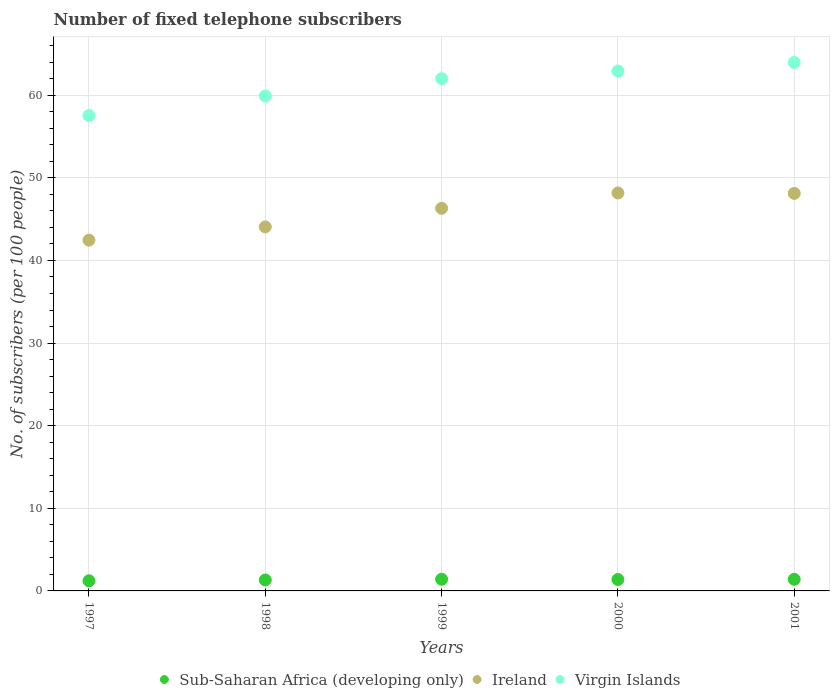How many different coloured dotlines are there?
Make the answer very short. 3. Is the number of dotlines equal to the number of legend labels?
Provide a short and direct response. Yes. What is the number of fixed telephone subscribers in Virgin Islands in 2001?
Your answer should be very brief. 63.96. Across all years, what is the maximum number of fixed telephone subscribers in Ireland?
Your answer should be compact. 48.16. Across all years, what is the minimum number of fixed telephone subscribers in Ireland?
Keep it short and to the point. 42.45. In which year was the number of fixed telephone subscribers in Sub-Saharan Africa (developing only) maximum?
Ensure brevity in your answer.  1999. What is the total number of fixed telephone subscribers in Ireland in the graph?
Your answer should be compact. 229.1. What is the difference between the number of fixed telephone subscribers in Ireland in 1997 and that in 1999?
Your answer should be very brief. -3.85. What is the difference between the number of fixed telephone subscribers in Sub-Saharan Africa (developing only) in 1997 and the number of fixed telephone subscribers in Virgin Islands in 2000?
Give a very brief answer. -61.7. What is the average number of fixed telephone subscribers in Ireland per year?
Provide a succinct answer. 45.82. In the year 1997, what is the difference between the number of fixed telephone subscribers in Virgin Islands and number of fixed telephone subscribers in Sub-Saharan Africa (developing only)?
Your response must be concise. 56.31. What is the ratio of the number of fixed telephone subscribers in Ireland in 1997 to that in 1998?
Provide a short and direct response. 0.96. Is the difference between the number of fixed telephone subscribers in Virgin Islands in 1999 and 2000 greater than the difference between the number of fixed telephone subscribers in Sub-Saharan Africa (developing only) in 1999 and 2000?
Offer a terse response. No. What is the difference between the highest and the second highest number of fixed telephone subscribers in Virgin Islands?
Your answer should be very brief. 1.03. What is the difference between the highest and the lowest number of fixed telephone subscribers in Sub-Saharan Africa (developing only)?
Your answer should be very brief. 0.19. In how many years, is the number of fixed telephone subscribers in Sub-Saharan Africa (developing only) greater than the average number of fixed telephone subscribers in Sub-Saharan Africa (developing only) taken over all years?
Offer a very short reply. 3. Does the number of fixed telephone subscribers in Ireland monotonically increase over the years?
Provide a short and direct response. No. Is the number of fixed telephone subscribers in Ireland strictly less than the number of fixed telephone subscribers in Virgin Islands over the years?
Offer a very short reply. Yes. How many years are there in the graph?
Keep it short and to the point. 5. What is the difference between two consecutive major ticks on the Y-axis?
Offer a terse response. 10. Are the values on the major ticks of Y-axis written in scientific E-notation?
Ensure brevity in your answer.  No. Does the graph contain any zero values?
Give a very brief answer. No. Does the graph contain grids?
Your answer should be compact. Yes. Where does the legend appear in the graph?
Ensure brevity in your answer.  Bottom center. What is the title of the graph?
Your response must be concise. Number of fixed telephone subscribers. What is the label or title of the X-axis?
Offer a very short reply. Years. What is the label or title of the Y-axis?
Provide a succinct answer. No. of subscribers (per 100 people). What is the No. of subscribers (per 100 people) of Sub-Saharan Africa (developing only) in 1997?
Your answer should be compact. 1.23. What is the No. of subscribers (per 100 people) in Ireland in 1997?
Your answer should be very brief. 42.45. What is the No. of subscribers (per 100 people) in Virgin Islands in 1997?
Give a very brief answer. 57.54. What is the No. of subscribers (per 100 people) in Sub-Saharan Africa (developing only) in 1998?
Give a very brief answer. 1.32. What is the No. of subscribers (per 100 people) of Ireland in 1998?
Your answer should be very brief. 44.06. What is the No. of subscribers (per 100 people) in Virgin Islands in 1998?
Give a very brief answer. 59.9. What is the No. of subscribers (per 100 people) in Sub-Saharan Africa (developing only) in 1999?
Offer a very short reply. 1.41. What is the No. of subscribers (per 100 people) in Ireland in 1999?
Your answer should be very brief. 46.31. What is the No. of subscribers (per 100 people) of Virgin Islands in 1999?
Give a very brief answer. 62. What is the No. of subscribers (per 100 people) of Sub-Saharan Africa (developing only) in 2000?
Ensure brevity in your answer.  1.38. What is the No. of subscribers (per 100 people) of Ireland in 2000?
Keep it short and to the point. 48.16. What is the No. of subscribers (per 100 people) in Virgin Islands in 2000?
Your answer should be very brief. 62.93. What is the No. of subscribers (per 100 people) of Sub-Saharan Africa (developing only) in 2001?
Offer a terse response. 1.4. What is the No. of subscribers (per 100 people) in Ireland in 2001?
Give a very brief answer. 48.11. What is the No. of subscribers (per 100 people) in Virgin Islands in 2001?
Make the answer very short. 63.96. Across all years, what is the maximum No. of subscribers (per 100 people) in Sub-Saharan Africa (developing only)?
Your response must be concise. 1.41. Across all years, what is the maximum No. of subscribers (per 100 people) of Ireland?
Your answer should be compact. 48.16. Across all years, what is the maximum No. of subscribers (per 100 people) of Virgin Islands?
Offer a very short reply. 63.96. Across all years, what is the minimum No. of subscribers (per 100 people) of Sub-Saharan Africa (developing only)?
Make the answer very short. 1.23. Across all years, what is the minimum No. of subscribers (per 100 people) of Ireland?
Your answer should be very brief. 42.45. Across all years, what is the minimum No. of subscribers (per 100 people) in Virgin Islands?
Give a very brief answer. 57.54. What is the total No. of subscribers (per 100 people) in Sub-Saharan Africa (developing only) in the graph?
Provide a short and direct response. 6.75. What is the total No. of subscribers (per 100 people) of Ireland in the graph?
Provide a succinct answer. 229.1. What is the total No. of subscribers (per 100 people) of Virgin Islands in the graph?
Provide a short and direct response. 306.32. What is the difference between the No. of subscribers (per 100 people) of Sub-Saharan Africa (developing only) in 1997 and that in 1998?
Your answer should be compact. -0.09. What is the difference between the No. of subscribers (per 100 people) in Ireland in 1997 and that in 1998?
Provide a short and direct response. -1.6. What is the difference between the No. of subscribers (per 100 people) of Virgin Islands in 1997 and that in 1998?
Offer a very short reply. -2.36. What is the difference between the No. of subscribers (per 100 people) in Sub-Saharan Africa (developing only) in 1997 and that in 1999?
Give a very brief answer. -0.19. What is the difference between the No. of subscribers (per 100 people) in Ireland in 1997 and that in 1999?
Your answer should be compact. -3.85. What is the difference between the No. of subscribers (per 100 people) in Virgin Islands in 1997 and that in 1999?
Make the answer very short. -4.47. What is the difference between the No. of subscribers (per 100 people) in Sub-Saharan Africa (developing only) in 1997 and that in 2000?
Your answer should be very brief. -0.15. What is the difference between the No. of subscribers (per 100 people) in Ireland in 1997 and that in 2000?
Your response must be concise. -5.71. What is the difference between the No. of subscribers (per 100 people) of Virgin Islands in 1997 and that in 2000?
Give a very brief answer. -5.39. What is the difference between the No. of subscribers (per 100 people) in Sub-Saharan Africa (developing only) in 1997 and that in 2001?
Ensure brevity in your answer.  -0.17. What is the difference between the No. of subscribers (per 100 people) in Ireland in 1997 and that in 2001?
Make the answer very short. -5.66. What is the difference between the No. of subscribers (per 100 people) in Virgin Islands in 1997 and that in 2001?
Provide a short and direct response. -6.42. What is the difference between the No. of subscribers (per 100 people) of Sub-Saharan Africa (developing only) in 1998 and that in 1999?
Your answer should be compact. -0.09. What is the difference between the No. of subscribers (per 100 people) in Ireland in 1998 and that in 1999?
Your response must be concise. -2.25. What is the difference between the No. of subscribers (per 100 people) in Virgin Islands in 1998 and that in 1999?
Ensure brevity in your answer.  -2.1. What is the difference between the No. of subscribers (per 100 people) of Sub-Saharan Africa (developing only) in 1998 and that in 2000?
Keep it short and to the point. -0.06. What is the difference between the No. of subscribers (per 100 people) in Ireland in 1998 and that in 2000?
Make the answer very short. -4.11. What is the difference between the No. of subscribers (per 100 people) in Virgin Islands in 1998 and that in 2000?
Keep it short and to the point. -3.03. What is the difference between the No. of subscribers (per 100 people) in Sub-Saharan Africa (developing only) in 1998 and that in 2001?
Ensure brevity in your answer.  -0.08. What is the difference between the No. of subscribers (per 100 people) in Ireland in 1998 and that in 2001?
Your response must be concise. -4.06. What is the difference between the No. of subscribers (per 100 people) in Virgin Islands in 1998 and that in 2001?
Offer a terse response. -4.06. What is the difference between the No. of subscribers (per 100 people) of Sub-Saharan Africa (developing only) in 1999 and that in 2000?
Your answer should be compact. 0.03. What is the difference between the No. of subscribers (per 100 people) in Ireland in 1999 and that in 2000?
Your response must be concise. -1.85. What is the difference between the No. of subscribers (per 100 people) of Virgin Islands in 1999 and that in 2000?
Make the answer very short. -0.93. What is the difference between the No. of subscribers (per 100 people) of Sub-Saharan Africa (developing only) in 1999 and that in 2001?
Offer a terse response. 0.01. What is the difference between the No. of subscribers (per 100 people) of Ireland in 1999 and that in 2001?
Provide a succinct answer. -1.8. What is the difference between the No. of subscribers (per 100 people) of Virgin Islands in 1999 and that in 2001?
Provide a succinct answer. -1.96. What is the difference between the No. of subscribers (per 100 people) of Sub-Saharan Africa (developing only) in 2000 and that in 2001?
Offer a very short reply. -0.02. What is the difference between the No. of subscribers (per 100 people) in Ireland in 2000 and that in 2001?
Offer a terse response. 0.05. What is the difference between the No. of subscribers (per 100 people) in Virgin Islands in 2000 and that in 2001?
Ensure brevity in your answer.  -1.03. What is the difference between the No. of subscribers (per 100 people) in Sub-Saharan Africa (developing only) in 1997 and the No. of subscribers (per 100 people) in Ireland in 1998?
Your answer should be very brief. -42.83. What is the difference between the No. of subscribers (per 100 people) in Sub-Saharan Africa (developing only) in 1997 and the No. of subscribers (per 100 people) in Virgin Islands in 1998?
Offer a very short reply. -58.67. What is the difference between the No. of subscribers (per 100 people) in Ireland in 1997 and the No. of subscribers (per 100 people) in Virgin Islands in 1998?
Make the answer very short. -17.44. What is the difference between the No. of subscribers (per 100 people) of Sub-Saharan Africa (developing only) in 1997 and the No. of subscribers (per 100 people) of Ireland in 1999?
Make the answer very short. -45.08. What is the difference between the No. of subscribers (per 100 people) in Sub-Saharan Africa (developing only) in 1997 and the No. of subscribers (per 100 people) in Virgin Islands in 1999?
Ensure brevity in your answer.  -60.77. What is the difference between the No. of subscribers (per 100 people) of Ireland in 1997 and the No. of subscribers (per 100 people) of Virgin Islands in 1999?
Ensure brevity in your answer.  -19.55. What is the difference between the No. of subscribers (per 100 people) of Sub-Saharan Africa (developing only) in 1997 and the No. of subscribers (per 100 people) of Ireland in 2000?
Your response must be concise. -46.93. What is the difference between the No. of subscribers (per 100 people) in Sub-Saharan Africa (developing only) in 1997 and the No. of subscribers (per 100 people) in Virgin Islands in 2000?
Offer a terse response. -61.7. What is the difference between the No. of subscribers (per 100 people) in Ireland in 1997 and the No. of subscribers (per 100 people) in Virgin Islands in 2000?
Provide a succinct answer. -20.47. What is the difference between the No. of subscribers (per 100 people) of Sub-Saharan Africa (developing only) in 1997 and the No. of subscribers (per 100 people) of Ireland in 2001?
Give a very brief answer. -46.88. What is the difference between the No. of subscribers (per 100 people) of Sub-Saharan Africa (developing only) in 1997 and the No. of subscribers (per 100 people) of Virgin Islands in 2001?
Offer a terse response. -62.73. What is the difference between the No. of subscribers (per 100 people) of Ireland in 1997 and the No. of subscribers (per 100 people) of Virgin Islands in 2001?
Your answer should be compact. -21.5. What is the difference between the No. of subscribers (per 100 people) of Sub-Saharan Africa (developing only) in 1998 and the No. of subscribers (per 100 people) of Ireland in 1999?
Your answer should be compact. -44.99. What is the difference between the No. of subscribers (per 100 people) in Sub-Saharan Africa (developing only) in 1998 and the No. of subscribers (per 100 people) in Virgin Islands in 1999?
Your response must be concise. -60.68. What is the difference between the No. of subscribers (per 100 people) in Ireland in 1998 and the No. of subscribers (per 100 people) in Virgin Islands in 1999?
Provide a short and direct response. -17.95. What is the difference between the No. of subscribers (per 100 people) of Sub-Saharan Africa (developing only) in 1998 and the No. of subscribers (per 100 people) of Ireland in 2000?
Keep it short and to the point. -46.84. What is the difference between the No. of subscribers (per 100 people) in Sub-Saharan Africa (developing only) in 1998 and the No. of subscribers (per 100 people) in Virgin Islands in 2000?
Your answer should be very brief. -61.6. What is the difference between the No. of subscribers (per 100 people) in Ireland in 1998 and the No. of subscribers (per 100 people) in Virgin Islands in 2000?
Your answer should be compact. -18.87. What is the difference between the No. of subscribers (per 100 people) in Sub-Saharan Africa (developing only) in 1998 and the No. of subscribers (per 100 people) in Ireland in 2001?
Keep it short and to the point. -46.79. What is the difference between the No. of subscribers (per 100 people) of Sub-Saharan Africa (developing only) in 1998 and the No. of subscribers (per 100 people) of Virgin Islands in 2001?
Your answer should be very brief. -62.63. What is the difference between the No. of subscribers (per 100 people) in Ireland in 1998 and the No. of subscribers (per 100 people) in Virgin Islands in 2001?
Keep it short and to the point. -19.9. What is the difference between the No. of subscribers (per 100 people) of Sub-Saharan Africa (developing only) in 1999 and the No. of subscribers (per 100 people) of Ireland in 2000?
Your response must be concise. -46.75. What is the difference between the No. of subscribers (per 100 people) of Sub-Saharan Africa (developing only) in 1999 and the No. of subscribers (per 100 people) of Virgin Islands in 2000?
Your answer should be compact. -61.51. What is the difference between the No. of subscribers (per 100 people) in Ireland in 1999 and the No. of subscribers (per 100 people) in Virgin Islands in 2000?
Make the answer very short. -16.62. What is the difference between the No. of subscribers (per 100 people) in Sub-Saharan Africa (developing only) in 1999 and the No. of subscribers (per 100 people) in Ireland in 2001?
Your answer should be compact. -46.7. What is the difference between the No. of subscribers (per 100 people) in Sub-Saharan Africa (developing only) in 1999 and the No. of subscribers (per 100 people) in Virgin Islands in 2001?
Offer a very short reply. -62.54. What is the difference between the No. of subscribers (per 100 people) in Ireland in 1999 and the No. of subscribers (per 100 people) in Virgin Islands in 2001?
Your answer should be compact. -17.65. What is the difference between the No. of subscribers (per 100 people) in Sub-Saharan Africa (developing only) in 2000 and the No. of subscribers (per 100 people) in Ireland in 2001?
Offer a terse response. -46.73. What is the difference between the No. of subscribers (per 100 people) of Sub-Saharan Africa (developing only) in 2000 and the No. of subscribers (per 100 people) of Virgin Islands in 2001?
Your answer should be compact. -62.58. What is the difference between the No. of subscribers (per 100 people) in Ireland in 2000 and the No. of subscribers (per 100 people) in Virgin Islands in 2001?
Make the answer very short. -15.79. What is the average No. of subscribers (per 100 people) in Sub-Saharan Africa (developing only) per year?
Ensure brevity in your answer.  1.35. What is the average No. of subscribers (per 100 people) in Ireland per year?
Offer a terse response. 45.82. What is the average No. of subscribers (per 100 people) of Virgin Islands per year?
Provide a succinct answer. 61.26. In the year 1997, what is the difference between the No. of subscribers (per 100 people) of Sub-Saharan Africa (developing only) and No. of subscribers (per 100 people) of Ireland?
Offer a terse response. -41.23. In the year 1997, what is the difference between the No. of subscribers (per 100 people) of Sub-Saharan Africa (developing only) and No. of subscribers (per 100 people) of Virgin Islands?
Ensure brevity in your answer.  -56.31. In the year 1997, what is the difference between the No. of subscribers (per 100 people) in Ireland and No. of subscribers (per 100 people) in Virgin Islands?
Provide a succinct answer. -15.08. In the year 1998, what is the difference between the No. of subscribers (per 100 people) in Sub-Saharan Africa (developing only) and No. of subscribers (per 100 people) in Ireland?
Your response must be concise. -42.73. In the year 1998, what is the difference between the No. of subscribers (per 100 people) of Sub-Saharan Africa (developing only) and No. of subscribers (per 100 people) of Virgin Islands?
Make the answer very short. -58.57. In the year 1998, what is the difference between the No. of subscribers (per 100 people) of Ireland and No. of subscribers (per 100 people) of Virgin Islands?
Offer a very short reply. -15.84. In the year 1999, what is the difference between the No. of subscribers (per 100 people) of Sub-Saharan Africa (developing only) and No. of subscribers (per 100 people) of Ireland?
Your answer should be compact. -44.89. In the year 1999, what is the difference between the No. of subscribers (per 100 people) of Sub-Saharan Africa (developing only) and No. of subscribers (per 100 people) of Virgin Islands?
Your response must be concise. -60.59. In the year 1999, what is the difference between the No. of subscribers (per 100 people) of Ireland and No. of subscribers (per 100 people) of Virgin Islands?
Give a very brief answer. -15.69. In the year 2000, what is the difference between the No. of subscribers (per 100 people) of Sub-Saharan Africa (developing only) and No. of subscribers (per 100 people) of Ireland?
Your answer should be compact. -46.78. In the year 2000, what is the difference between the No. of subscribers (per 100 people) of Sub-Saharan Africa (developing only) and No. of subscribers (per 100 people) of Virgin Islands?
Provide a succinct answer. -61.55. In the year 2000, what is the difference between the No. of subscribers (per 100 people) in Ireland and No. of subscribers (per 100 people) in Virgin Islands?
Make the answer very short. -14.76. In the year 2001, what is the difference between the No. of subscribers (per 100 people) in Sub-Saharan Africa (developing only) and No. of subscribers (per 100 people) in Ireland?
Provide a short and direct response. -46.71. In the year 2001, what is the difference between the No. of subscribers (per 100 people) of Sub-Saharan Africa (developing only) and No. of subscribers (per 100 people) of Virgin Islands?
Keep it short and to the point. -62.55. In the year 2001, what is the difference between the No. of subscribers (per 100 people) of Ireland and No. of subscribers (per 100 people) of Virgin Islands?
Your answer should be compact. -15.84. What is the ratio of the No. of subscribers (per 100 people) in Sub-Saharan Africa (developing only) in 1997 to that in 1998?
Your answer should be compact. 0.93. What is the ratio of the No. of subscribers (per 100 people) in Ireland in 1997 to that in 1998?
Ensure brevity in your answer.  0.96. What is the ratio of the No. of subscribers (per 100 people) of Virgin Islands in 1997 to that in 1998?
Offer a very short reply. 0.96. What is the ratio of the No. of subscribers (per 100 people) of Sub-Saharan Africa (developing only) in 1997 to that in 1999?
Give a very brief answer. 0.87. What is the ratio of the No. of subscribers (per 100 people) in Ireland in 1997 to that in 1999?
Provide a succinct answer. 0.92. What is the ratio of the No. of subscribers (per 100 people) in Virgin Islands in 1997 to that in 1999?
Your response must be concise. 0.93. What is the ratio of the No. of subscribers (per 100 people) of Sub-Saharan Africa (developing only) in 1997 to that in 2000?
Provide a short and direct response. 0.89. What is the ratio of the No. of subscribers (per 100 people) in Ireland in 1997 to that in 2000?
Ensure brevity in your answer.  0.88. What is the ratio of the No. of subscribers (per 100 people) of Virgin Islands in 1997 to that in 2000?
Ensure brevity in your answer.  0.91. What is the ratio of the No. of subscribers (per 100 people) of Sub-Saharan Africa (developing only) in 1997 to that in 2001?
Keep it short and to the point. 0.88. What is the ratio of the No. of subscribers (per 100 people) of Ireland in 1997 to that in 2001?
Offer a terse response. 0.88. What is the ratio of the No. of subscribers (per 100 people) in Virgin Islands in 1997 to that in 2001?
Provide a succinct answer. 0.9. What is the ratio of the No. of subscribers (per 100 people) in Sub-Saharan Africa (developing only) in 1998 to that in 1999?
Provide a short and direct response. 0.93. What is the ratio of the No. of subscribers (per 100 people) of Ireland in 1998 to that in 1999?
Provide a short and direct response. 0.95. What is the ratio of the No. of subscribers (per 100 people) in Virgin Islands in 1998 to that in 1999?
Your answer should be very brief. 0.97. What is the ratio of the No. of subscribers (per 100 people) in Sub-Saharan Africa (developing only) in 1998 to that in 2000?
Offer a terse response. 0.96. What is the ratio of the No. of subscribers (per 100 people) of Ireland in 1998 to that in 2000?
Make the answer very short. 0.91. What is the ratio of the No. of subscribers (per 100 people) in Virgin Islands in 1998 to that in 2000?
Keep it short and to the point. 0.95. What is the ratio of the No. of subscribers (per 100 people) in Sub-Saharan Africa (developing only) in 1998 to that in 2001?
Your answer should be compact. 0.94. What is the ratio of the No. of subscribers (per 100 people) of Ireland in 1998 to that in 2001?
Ensure brevity in your answer.  0.92. What is the ratio of the No. of subscribers (per 100 people) of Virgin Islands in 1998 to that in 2001?
Offer a terse response. 0.94. What is the ratio of the No. of subscribers (per 100 people) in Sub-Saharan Africa (developing only) in 1999 to that in 2000?
Ensure brevity in your answer.  1.02. What is the ratio of the No. of subscribers (per 100 people) of Ireland in 1999 to that in 2000?
Your response must be concise. 0.96. What is the ratio of the No. of subscribers (per 100 people) of Virgin Islands in 1999 to that in 2000?
Keep it short and to the point. 0.99. What is the ratio of the No. of subscribers (per 100 people) in Sub-Saharan Africa (developing only) in 1999 to that in 2001?
Keep it short and to the point. 1.01. What is the ratio of the No. of subscribers (per 100 people) of Ireland in 1999 to that in 2001?
Provide a short and direct response. 0.96. What is the ratio of the No. of subscribers (per 100 people) of Virgin Islands in 1999 to that in 2001?
Your response must be concise. 0.97. What is the ratio of the No. of subscribers (per 100 people) in Sub-Saharan Africa (developing only) in 2000 to that in 2001?
Your answer should be compact. 0.98. What is the ratio of the No. of subscribers (per 100 people) in Virgin Islands in 2000 to that in 2001?
Provide a short and direct response. 0.98. What is the difference between the highest and the second highest No. of subscribers (per 100 people) in Sub-Saharan Africa (developing only)?
Provide a succinct answer. 0.01. What is the difference between the highest and the second highest No. of subscribers (per 100 people) in Ireland?
Provide a succinct answer. 0.05. What is the difference between the highest and the second highest No. of subscribers (per 100 people) of Virgin Islands?
Give a very brief answer. 1.03. What is the difference between the highest and the lowest No. of subscribers (per 100 people) of Sub-Saharan Africa (developing only)?
Give a very brief answer. 0.19. What is the difference between the highest and the lowest No. of subscribers (per 100 people) of Ireland?
Ensure brevity in your answer.  5.71. What is the difference between the highest and the lowest No. of subscribers (per 100 people) of Virgin Islands?
Your answer should be compact. 6.42. 